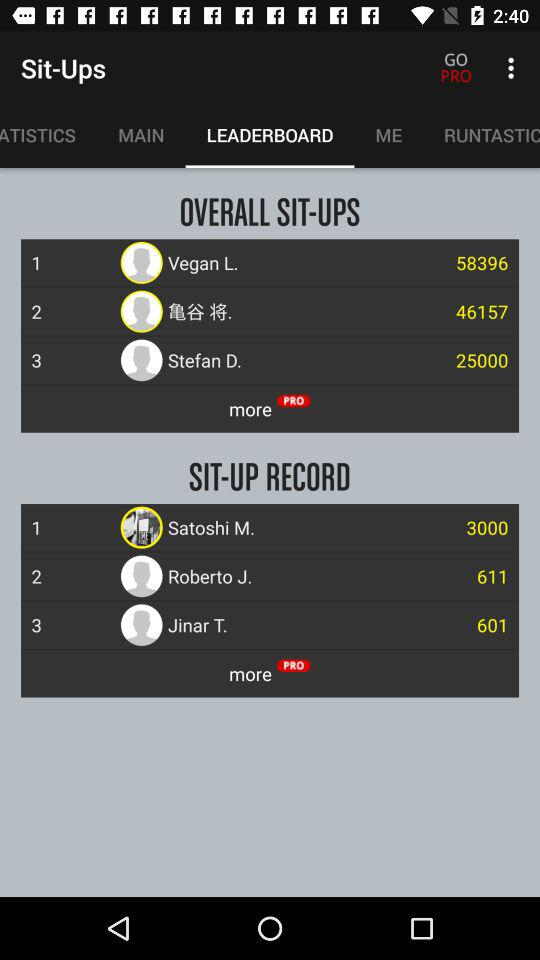What is the "OVERALL SIT-UPS" record of Vegan L.? There are 58396 sit-ups. 